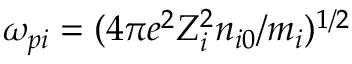<formula> <loc_0><loc_0><loc_500><loc_500>\omega _ { p i } = ( 4 \pi e ^ { 2 } Z _ { i } ^ { 2 } n _ { i 0 } / m _ { i } ) ^ { 1 / 2 }</formula> 